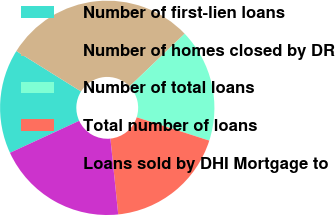Convert chart to OTSL. <chart><loc_0><loc_0><loc_500><loc_500><pie_chart><fcel>Number of first-lien loans<fcel>Number of homes closed by DR<fcel>Number of total loans<fcel>Total number of loans<fcel>Loans sold by DHI Mortgage to<nl><fcel>15.78%<fcel>28.96%<fcel>17.1%<fcel>18.42%<fcel>19.74%<nl></chart> 